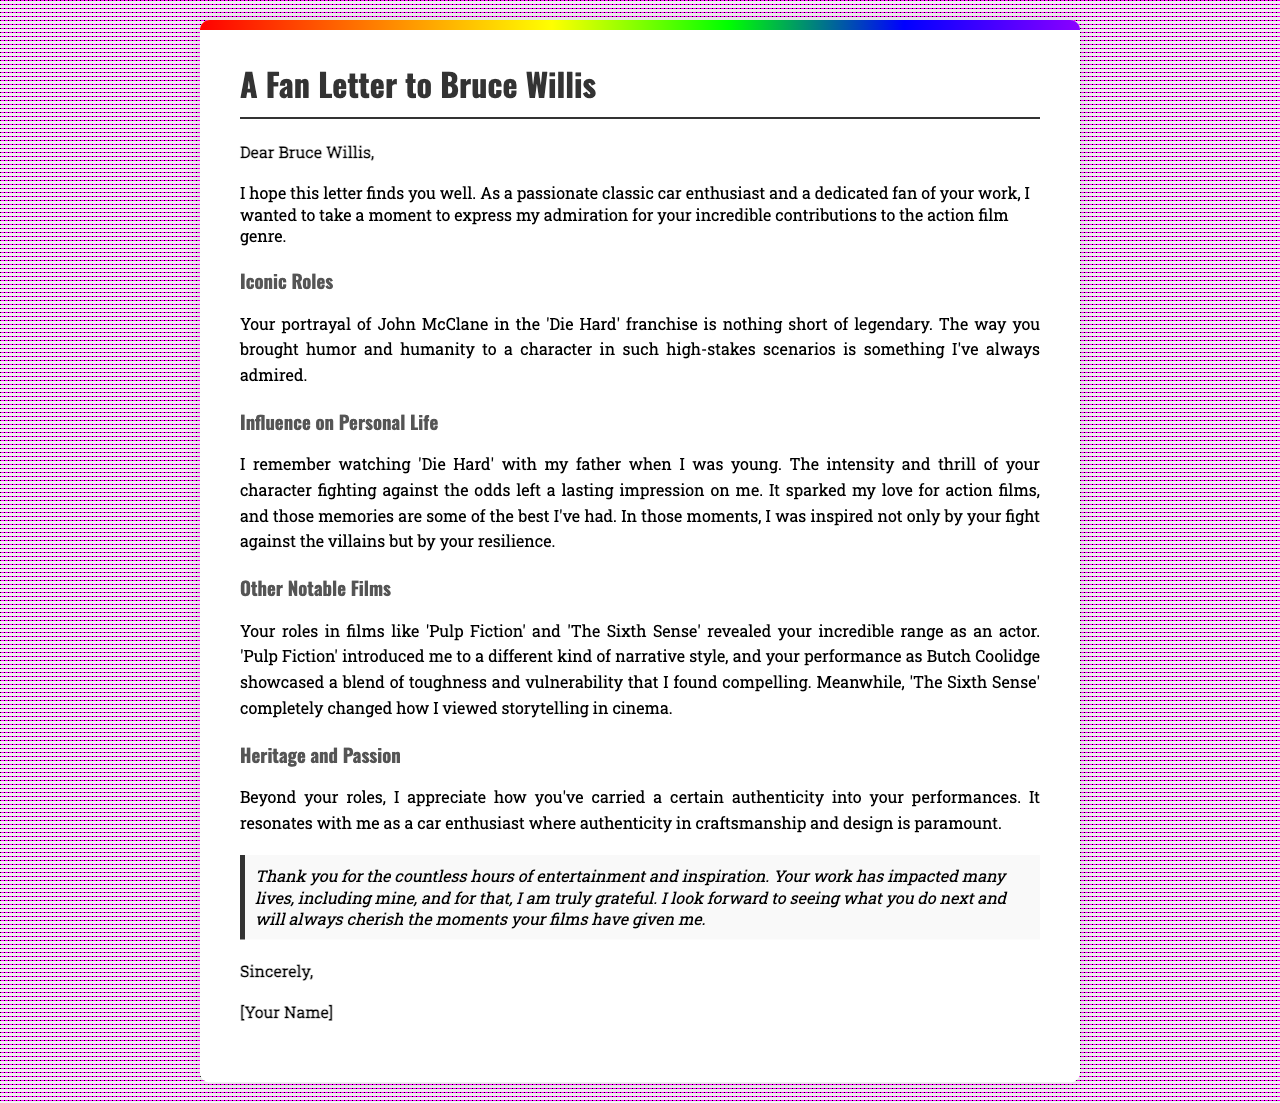What are the iconic roles mentioned? The letter mentions the roles of John McClane from 'Die Hard', Butch Coolidge from 'Pulp Fiction', and a character from 'The Sixth Sense'.
Answer: John McClane, Butch Coolidge Who is the recipient of the letter? The salutation indicates that the letter is addressed to Bruce Willis.
Answer: Bruce Willis What memory is recalled related to 'Die Hard'? The author recalls watching 'Die Hard' with their father, which sparked their love for action films.
Answer: Watching 'Die Hard' with my father What does the writer feel about Bruce Willis's portrayal of John McClane? The writer admires the way Bruce Willis brought humor and humanity to a high-stakes character.
Answer: Humor and humanity In which film did Bruce Willis showcase toughness and vulnerability? The writer refers to Bruce Willis's performance in 'Pulp Fiction' as showcasing toughness and vulnerability.
Answer: Pulp Fiction 